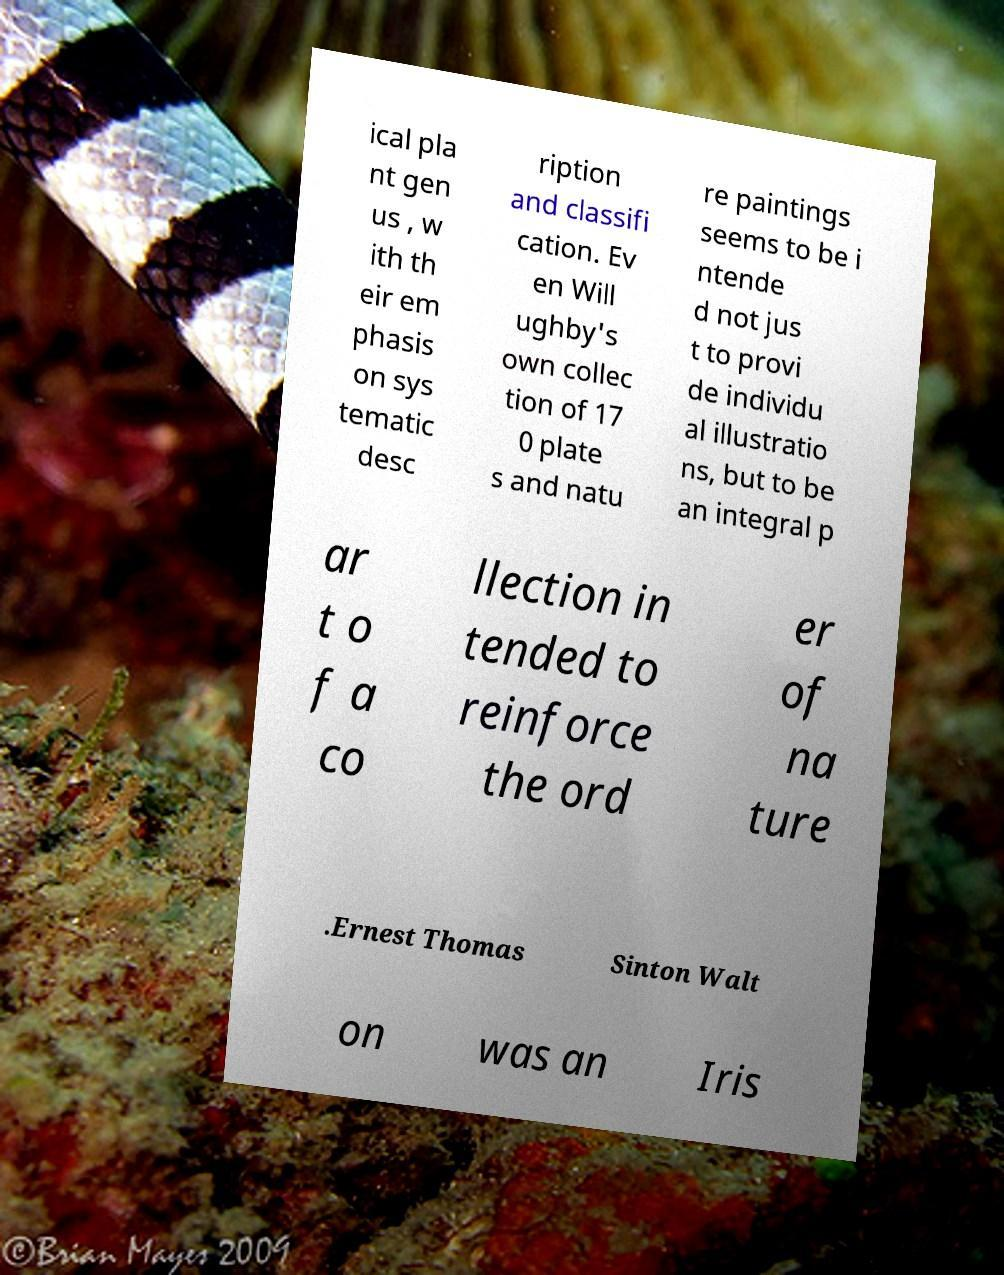Can you read and provide the text displayed in the image?This photo seems to have some interesting text. Can you extract and type it out for me? ical pla nt gen us , w ith th eir em phasis on sys tematic desc ription and classifi cation. Ev en Will ughby's own collec tion of 17 0 plate s and natu re paintings seems to be i ntende d not jus t to provi de individu al illustratio ns, but to be an integral p ar t o f a co llection in tended to reinforce the ord er of na ture .Ernest Thomas Sinton Walt on was an Iris 